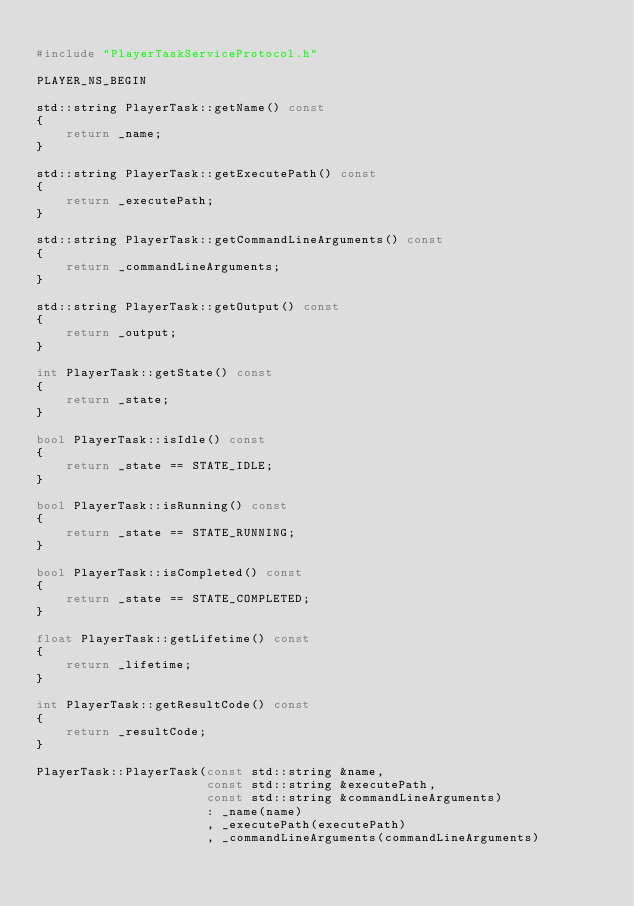<code> <loc_0><loc_0><loc_500><loc_500><_C++_>
#include "PlayerTaskServiceProtocol.h"

PLAYER_NS_BEGIN

std::string PlayerTask::getName() const
{
    return _name;
}

std::string PlayerTask::getExecutePath() const
{
    return _executePath;
}

std::string PlayerTask::getCommandLineArguments() const
{
    return _commandLineArguments;
}

std::string PlayerTask::getOutput() const
{
    return _output;
}

int PlayerTask::getState() const
{
    return _state;
}

bool PlayerTask::isIdle() const
{
    return _state == STATE_IDLE;
}

bool PlayerTask::isRunning() const
{
    return _state == STATE_RUNNING;
}

bool PlayerTask::isCompleted() const
{
    return _state == STATE_COMPLETED;
}

float PlayerTask::getLifetime() const
{
    return _lifetime;
}

int PlayerTask::getResultCode() const
{
    return _resultCode;
}

PlayerTask::PlayerTask(const std::string &name,
                       const std::string &executePath,
                       const std::string &commandLineArguments)
                       : _name(name)
                       , _executePath(executePath)
                       , _commandLineArguments(commandLineArguments)</code> 